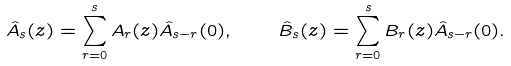Convert formula to latex. <formula><loc_0><loc_0><loc_500><loc_500>\hat { A } _ { s } ( z ) = \sum _ { r = 0 } ^ { s } A _ { r } ( z ) \hat { A } _ { s - r } ( 0 ) , \quad \hat { B } _ { s } ( z ) = \sum _ { r = 0 } ^ { s } B _ { r } ( z ) \hat { A } _ { s - r } ( 0 ) .</formula> 